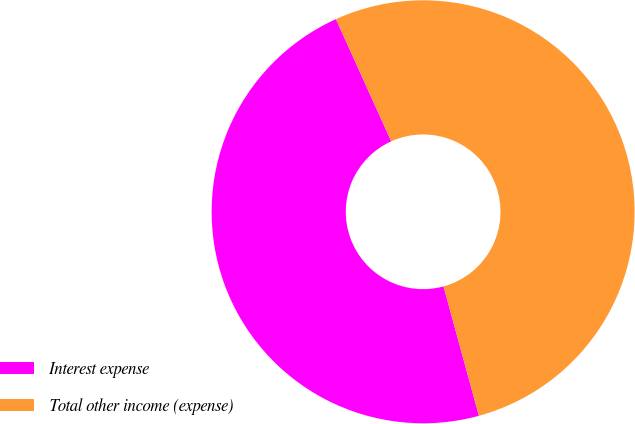Convert chart. <chart><loc_0><loc_0><loc_500><loc_500><pie_chart><fcel>Interest expense<fcel>Total other income (expense)<nl><fcel>47.49%<fcel>52.51%<nl></chart> 